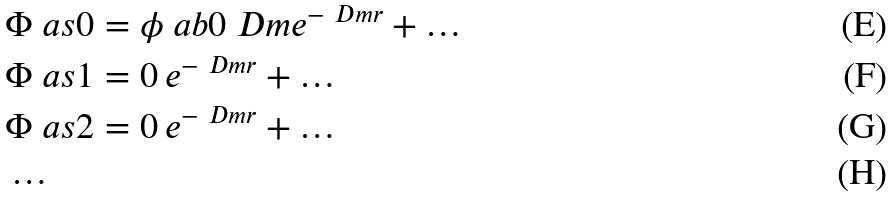Convert formula to latex. <formula><loc_0><loc_0><loc_500><loc_500>& \Phi \ a s { 0 } = \phi \ a b { 0 } { \ D m } e ^ { - \ D m r } + \dots \\ & \Phi \ a s { 1 } = 0 \, e ^ { - \ D m r } + \dots \\ & \Phi \ a s { 2 } = 0 \, e ^ { - \ D m r } + \dots \\ & \dots</formula> 